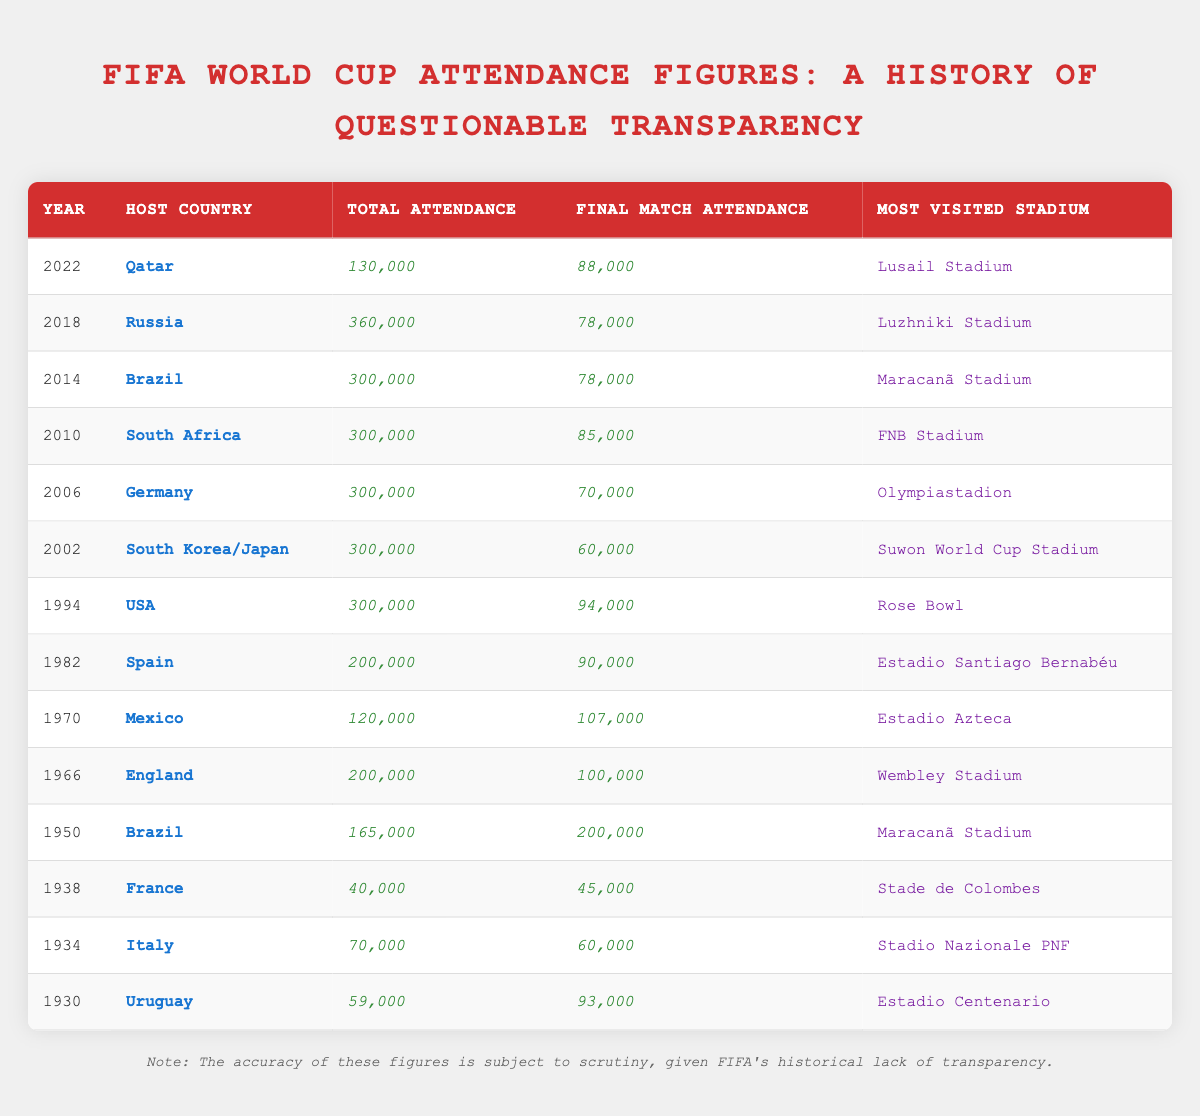What was the total attendance at the FIFA World Cup in 1950? The table lists the total attendance for the year 1950 as 165,000.
Answer: 165,000 Which World Cup had the highest total attendance? The highest total attendance is found in 1994 with 300,000 attendees, which appears in multiple entries but is tied for the largest number.
Answer: 1994 (300,000) What is the average final match attendance across all years listed in the table? To find the average, we add all final match attendances: (93,000 + 60,000 + 45,000 + 200,000 + 100,000 + 107,000 + 90,000 + 94,000 + 60,000 + 70,000 + 85,000 + 78,000 + 78,000 + 88,000) = 1,056,000. There are 14 values, so 1,056,000 / 14 = 75,428 (approx).
Answer: 75,428 Which stadium was the most visited during the 2014 World Cup? The table indicates that the most visited stadium during the 2014 World Cup in Brazil was the Maracanã Stadium.
Answer: Maracanã Stadium Did any World Cup host country have a total attendance below 100,000? Yes, the table shows that the total attendance for the World Cup in France in 1938 was only 40,000, which is below 100,000.
Answer: Yes What is the difference in final match attendance between 1950 and 1966? The final match attendance in 1950 was 200,000 and in 1966 it was 100,000. The difference is 200,000 - 100,000 = 100,000.
Answer: 100,000 Which host country had the lowest total attendance? The table shows that the lowest total attendance was in 1938 when France hosted, with only 40,000 attendees.
Answer: France (40,000) Identify the year with the highest final match attendance. The final match attendance was highest in 1950, with 200,000 attendees.
Answer: 1950 (200,000) How many World Cups had a total attendance of 300,000? The table shows that there are four instances (1994, 2002, 2006, and 2010) where the total attendance was 300,000.
Answer: 4 Was the most visited stadium in 1966 the same as in 2010? The most visited stadium in 1966 was Wembley Stadium and in 2010 was FNB Stadium, hence they are different.
Answer: No What was the trend of total attendance from 1930 to 2022? By analyzing each entry, total attendance started low in 1930 and fluctuated, reaching a peak at 300,000 in several editions while falling dramatically again in 2022 (130,000). The trend highlights inconsistency over the years.
Answer: Fluctuating with a peak at 300,000 and drop to 130,000 in 2022 